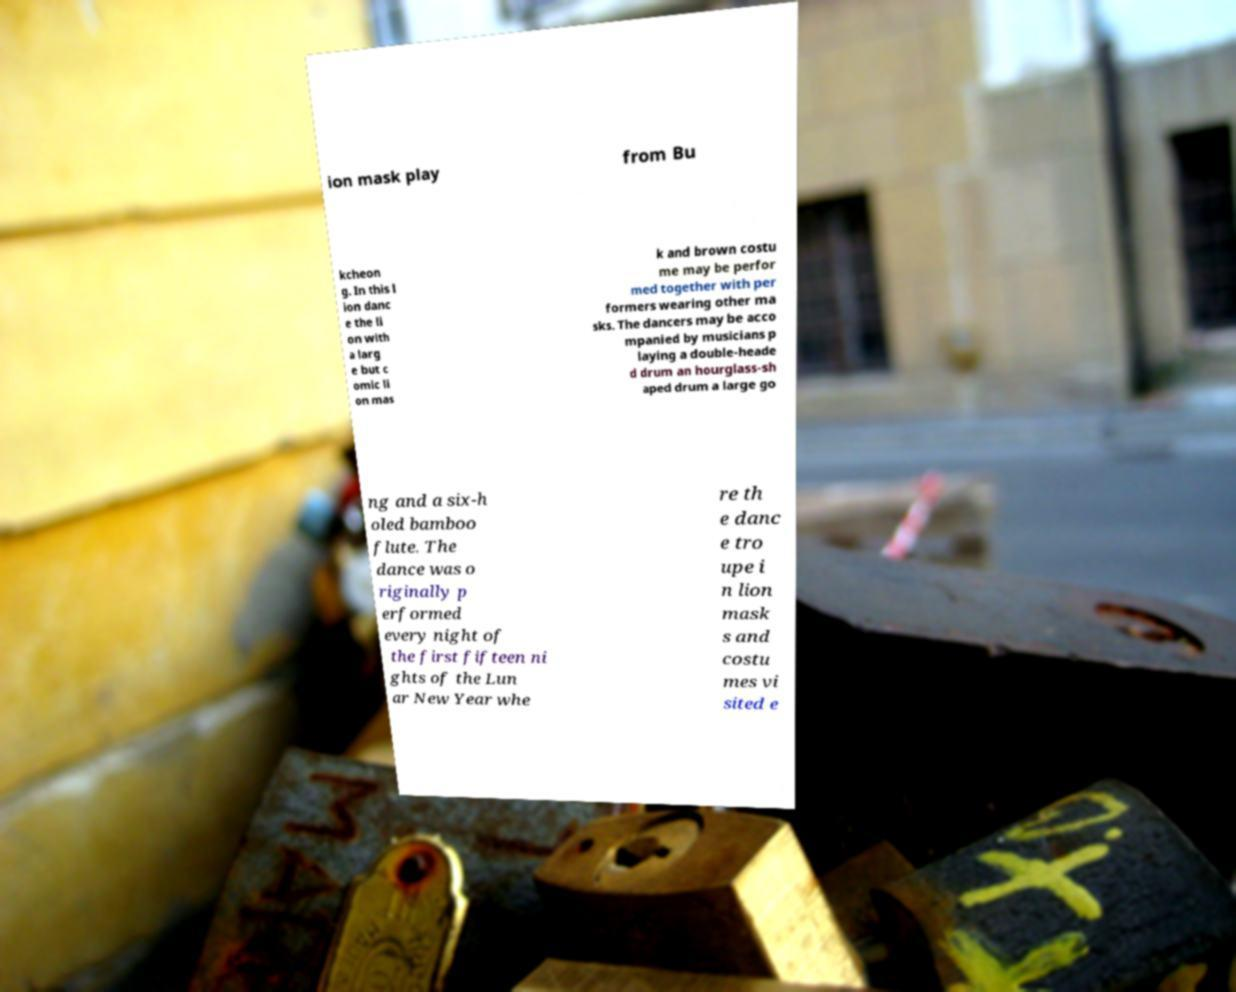Could you extract and type out the text from this image? ion mask play from Bu kcheon g. In this l ion danc e the li on with a larg e but c omic li on mas k and brown costu me may be perfor med together with per formers wearing other ma sks. The dancers may be acco mpanied by musicians p laying a double-heade d drum an hourglass-sh aped drum a large go ng and a six-h oled bamboo flute. The dance was o riginally p erformed every night of the first fifteen ni ghts of the Lun ar New Year whe re th e danc e tro upe i n lion mask s and costu mes vi sited e 